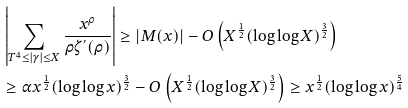<formula> <loc_0><loc_0><loc_500><loc_500>& \left | \sum _ { T ^ { 4 } \leq | \gamma | \leq X } \frac { x ^ { \rho } } { \rho \zeta ^ { ^ { \prime } } ( \rho ) } \right | \geq | M ( x ) | - O \left ( X ^ { \frac { 1 } { 2 } } ( \log \log X ) ^ { \frac { 3 } { 2 } } \right ) \\ & \geq \alpha x ^ { \frac { 1 } { 2 } } ( \log \log x ) ^ { \frac { 3 } { 2 } } - O \left ( X ^ { \frac { 1 } { 2 } } ( \log \log X ) ^ { \frac { 3 } { 2 } } \right ) \geq x ^ { \frac { 1 } { 2 } } ( \log \log x ) ^ { \frac { 5 } { 4 } } \\</formula> 